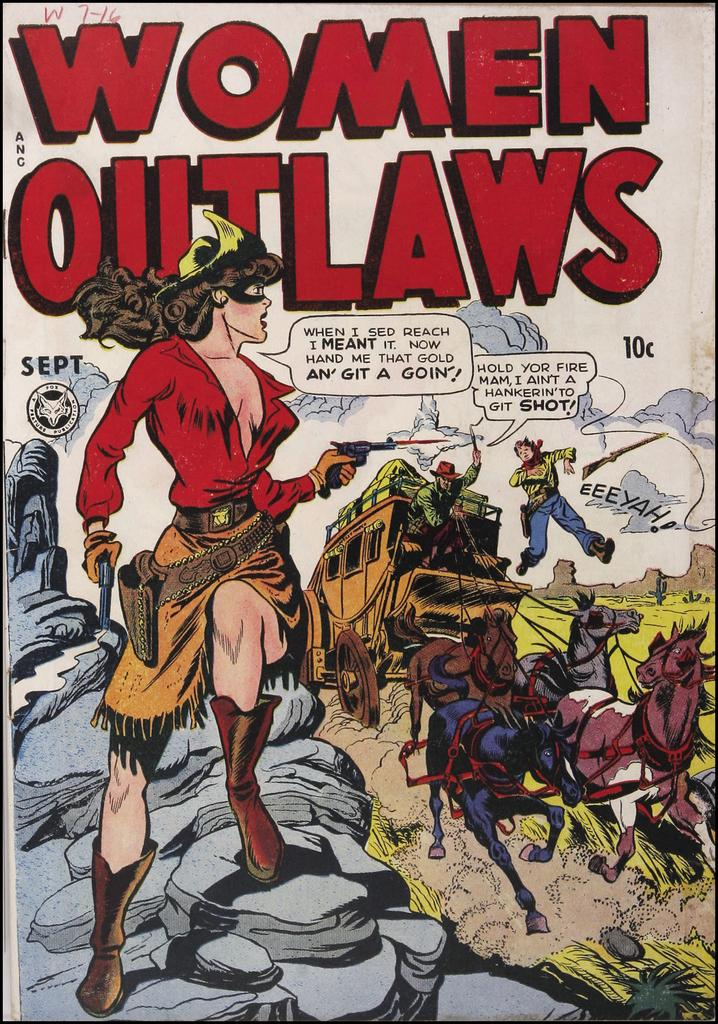<image>
Render a clear and concise summary of the photo. The September edition of the comic series Women Outlaws. 